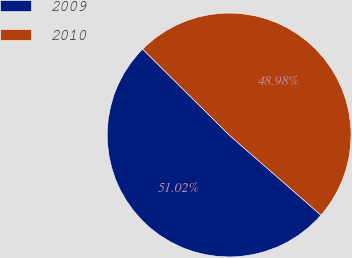Convert chart to OTSL. <chart><loc_0><loc_0><loc_500><loc_500><pie_chart><fcel>2009<fcel>2010<nl><fcel>51.02%<fcel>48.98%<nl></chart> 